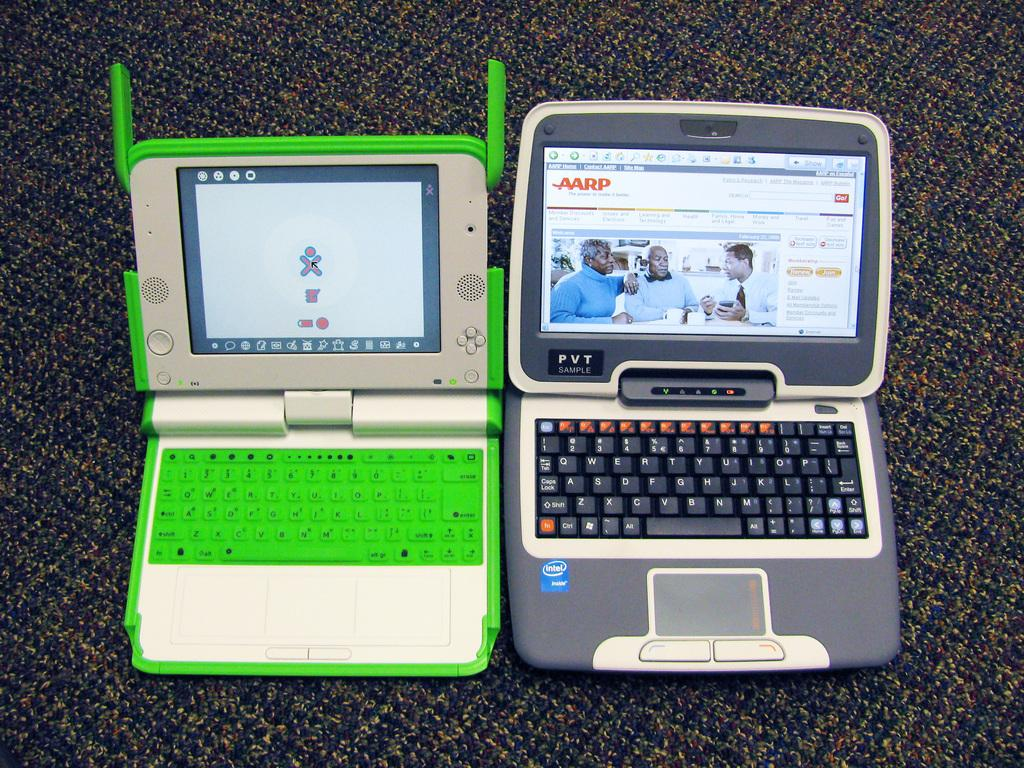How many devices are present in the image? There are two devices in the image. What can be seen on the screens of the devices? The screens of the devices display a group of people, and there is text visible on the screens. What feature do the devices have for typing or inputting information? The devices have keyboards. What is located at the bottom of the image? There is a mat at the bottom of the image. What type of cheese is being weighed on the scale in the image? There is no scale or cheese present in the image. What scientific theory is being discussed on the devices in the image? The image does not show any discussion of scientific theories; it only displays a group of people on the screens of the devices. 